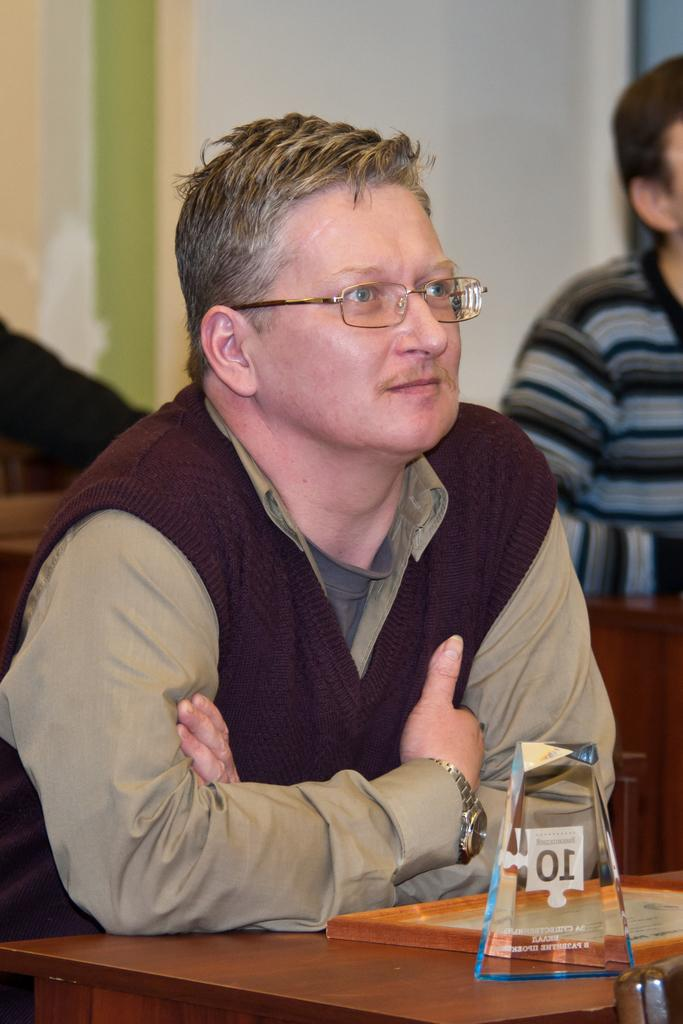What is the man in the image doing? The man is sitting in the image. What is in front of the man? The man is in front of a table. How many objects are on the table? There are two objects on the table. Can you describe the person behind the man? There is another person behind the man. How would you describe the background of the image? The background of the image is blurry. What type of religious symbol can be seen on the table in the image? There is no religious symbol present on the table in the image. Can you describe the snake that is slithering across the man's lap in the image? There is no snake present in the image; the man is simply sitting in front of a table. 